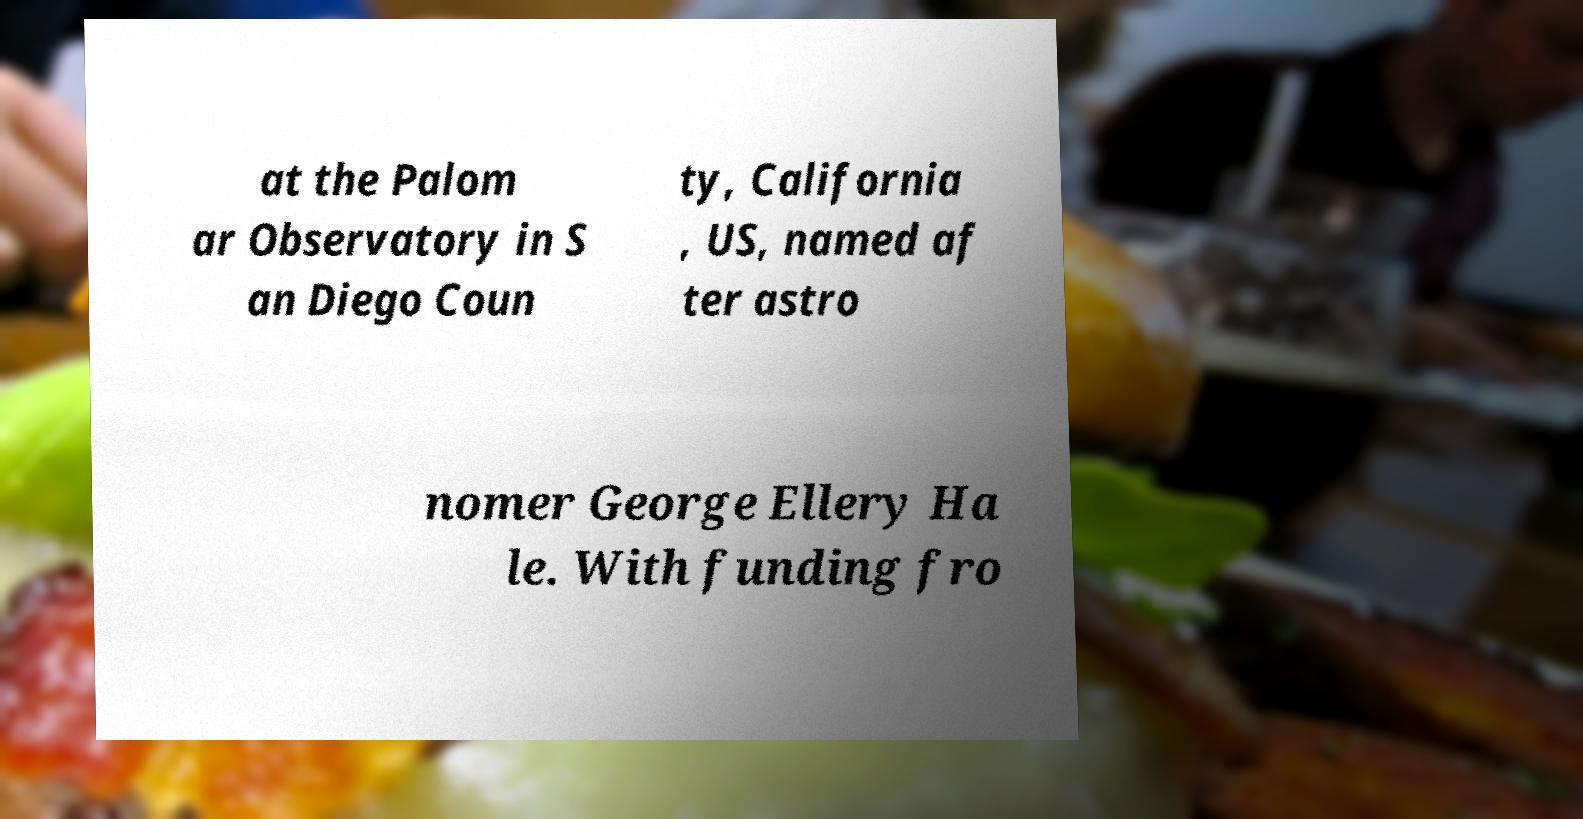What messages or text are displayed in this image? I need them in a readable, typed format. at the Palom ar Observatory in S an Diego Coun ty, California , US, named af ter astro nomer George Ellery Ha le. With funding fro 